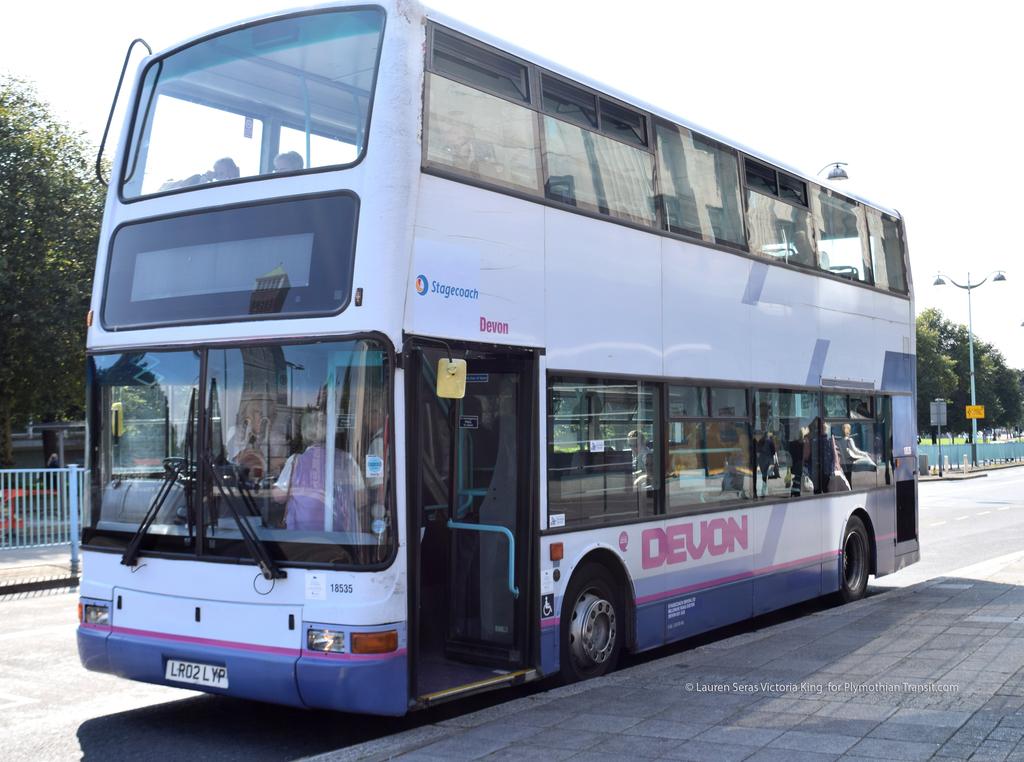What is the name of the bus?
Provide a short and direct response. Devon. What is the license plate number?
Provide a succinct answer. Lr02lyp. 